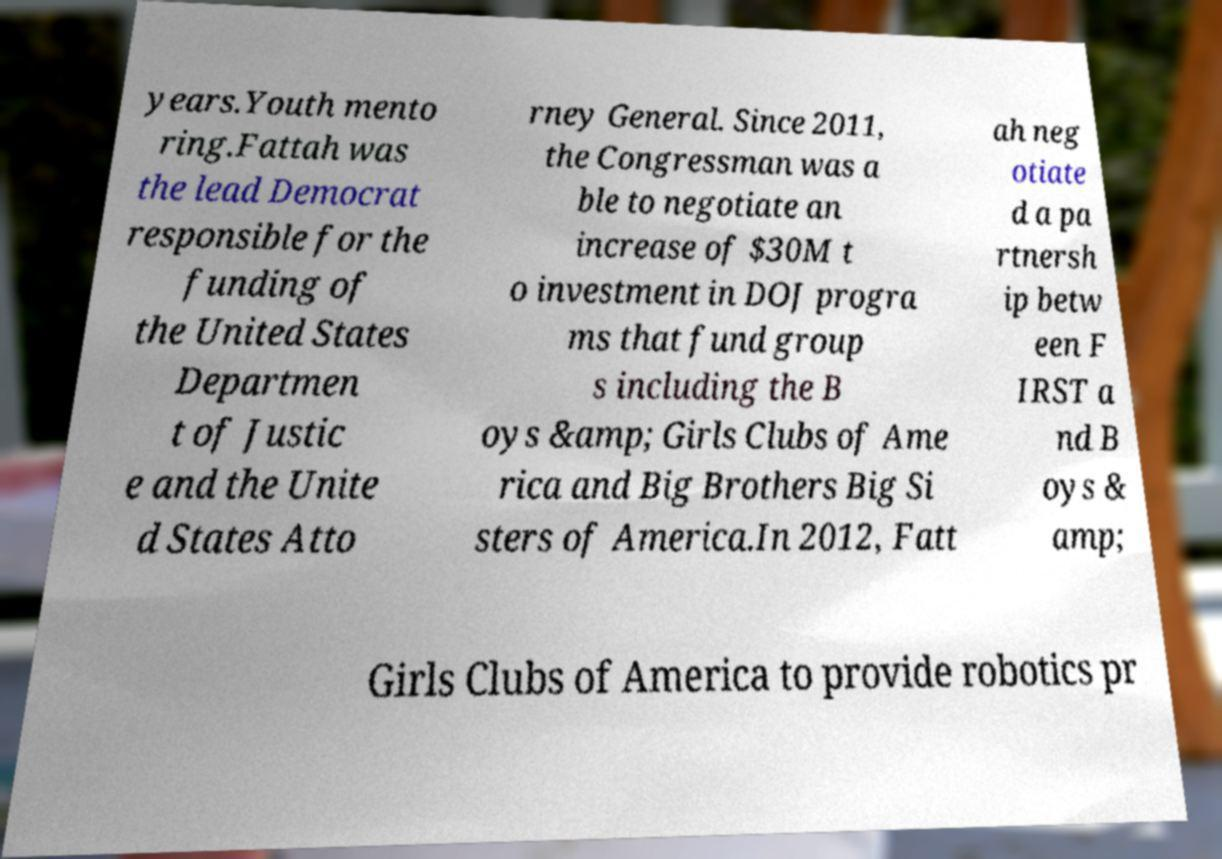Could you extract and type out the text from this image? years.Youth mento ring.Fattah was the lead Democrat responsible for the funding of the United States Departmen t of Justic e and the Unite d States Atto rney General. Since 2011, the Congressman was a ble to negotiate an increase of $30M t o investment in DOJ progra ms that fund group s including the B oys &amp; Girls Clubs of Ame rica and Big Brothers Big Si sters of America.In 2012, Fatt ah neg otiate d a pa rtnersh ip betw een F IRST a nd B oys & amp; Girls Clubs of America to provide robotics pr 